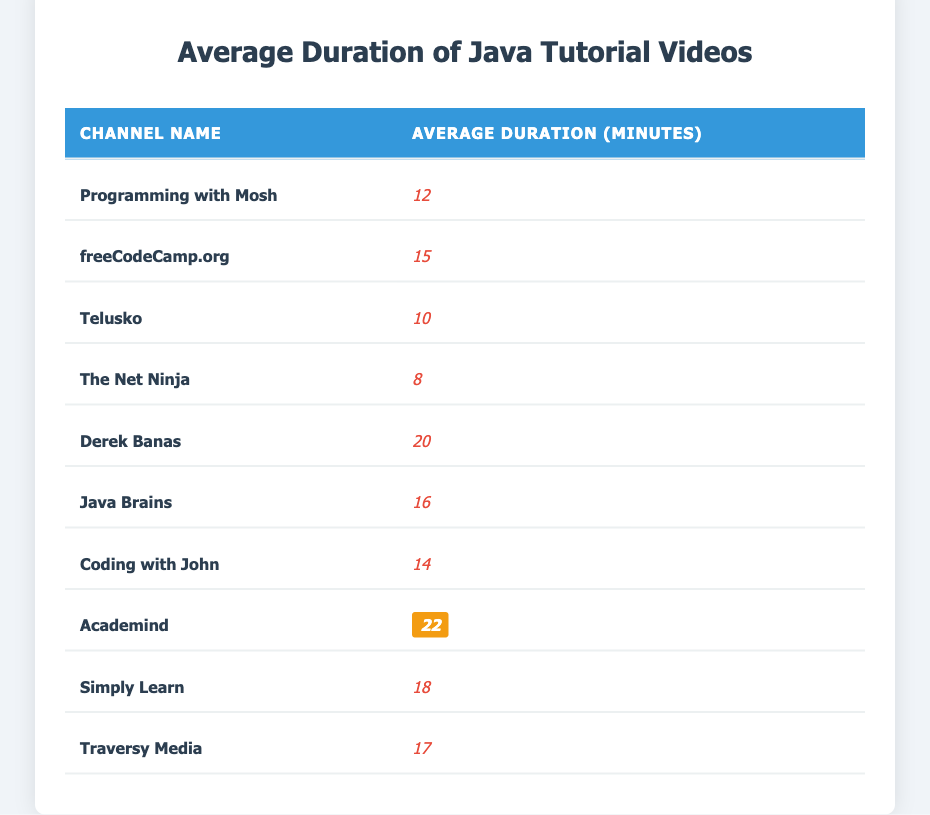What is the average duration of tutorial videos from Derek Banas? According to the table, the average duration of Derek Banas's tutorial videos is listed directly as 20 minutes.
Answer: 20 minutes Which channel has the shortest average video duration? The channel with the shortest average video duration is The Net Ninja, which has an average of 8 minutes.
Answer: The Net Ninja What is the average duration of videos from Java Brains and Coding with John combined? To find the combined average, I add the average durations: 16 minutes (Java Brains) + 14 minutes (Coding with John) = 30 minutes. Since there are 2 channels, I divide by 2: 30 / 2 = 15 minutes.
Answer: 15 minutes Does Academind have the longest average video duration? Yes, Academind has an average video duration of 22 minutes, which is the highest among all listed channels.
Answer: Yes What is the difference in average duration between the longest and shortest channels? To find the difference, subtract the shortest duration (8 minutes from The Net Ninja) from the longest duration (22 minutes from Academind): 22 - 8 = 14 minutes.
Answer: 14 minutes Calculate the average duration of the tutorial videos across all channels. First, I sum the average durations: 12 + 15 + 10 + 8 + 20 + 16 + 14 + 22 + 18 + 17 = 142 minutes. There are 10 channels, so I divide the total by 10: 142 / 10 = 14.2 minutes.
Answer: 14.2 minutes Which channel has a higher average video duration, freeCodeCamp.org or Simply Learn? freeCodeCamp.org has an average of 15 minutes, while Simply Learn has an average of 18 minutes. Thus, Simply Learn has a higher duration than freeCodeCamp.org.
Answer: Simply Learn Is the average duration of videos on Telusko greater than 12 minutes? No, Telusko has an average duration of 10 minutes, which is less than 12 minutes.
Answer: No How many channels have an average video duration greater than 15 minutes? The channels with durations greater than 15 minutes are Derek Banas (20), Java Brains (16), Academind (22), and Simply Learn (18), totaling 4 channels.
Answer: 4 channels 